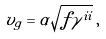<formula> <loc_0><loc_0><loc_500><loc_500>v _ { g } = \alpha \sqrt { f \gamma ^ { i i } } \, ,</formula> 